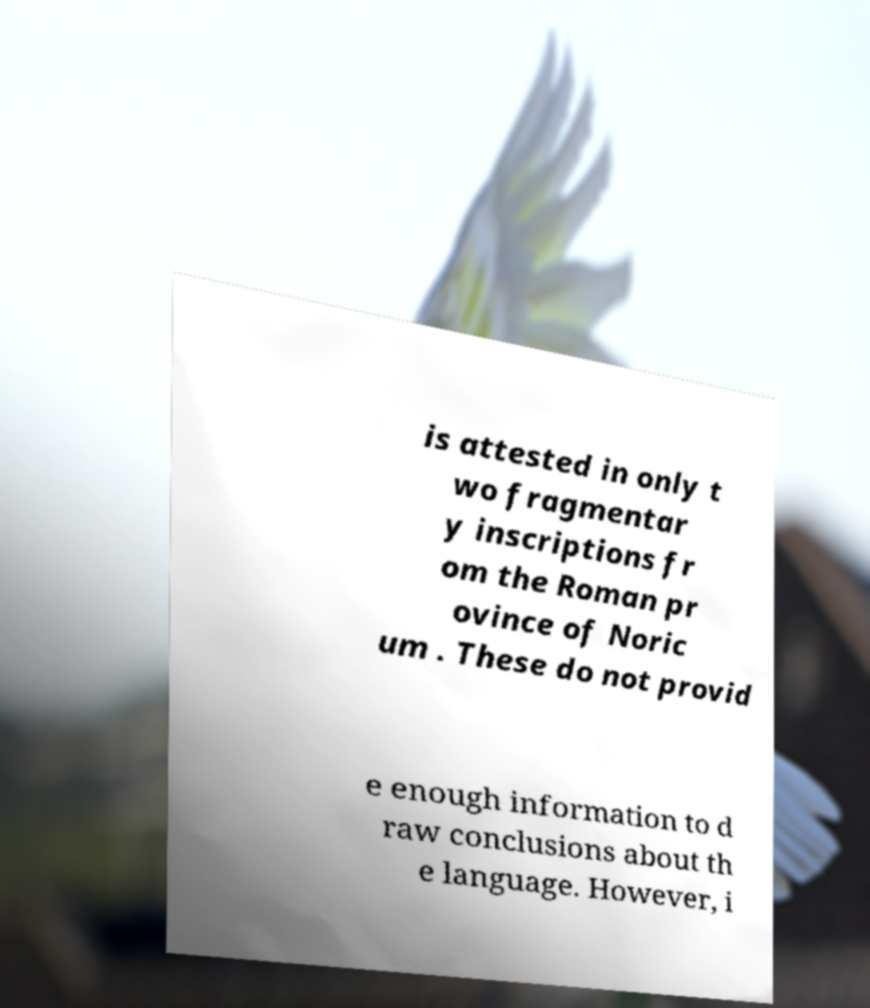Can you read and provide the text displayed in the image?This photo seems to have some interesting text. Can you extract and type it out for me? is attested in only t wo fragmentar y inscriptions fr om the Roman pr ovince of Noric um . These do not provid e enough information to d raw conclusions about th e language. However, i 